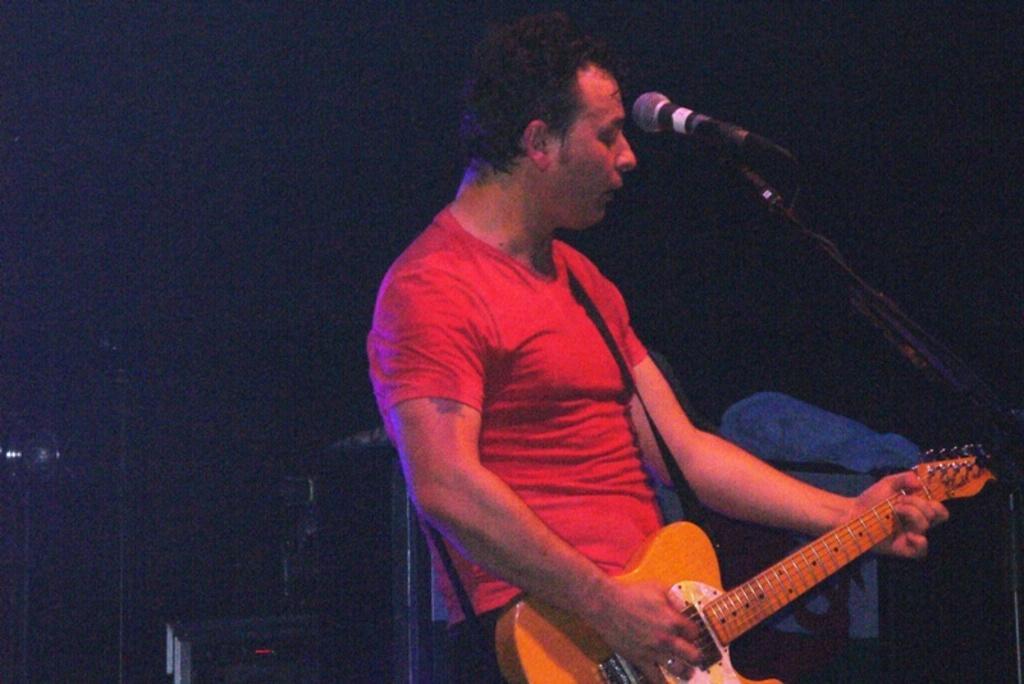Please provide a concise description of this image. On the background of the picture it's very dark. Here we can see one man wearing a red shirt standing in front of a mike and playing a guitar. 